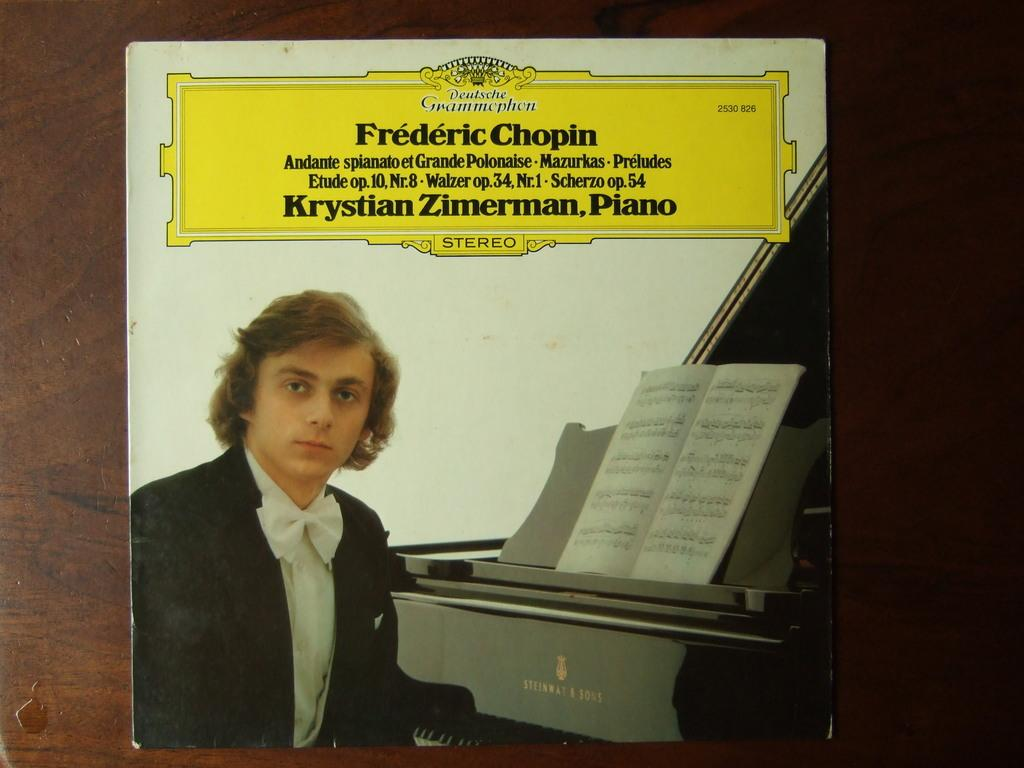<image>
Write a terse but informative summary of the picture. An album with music by Chopin is displayed on a table 